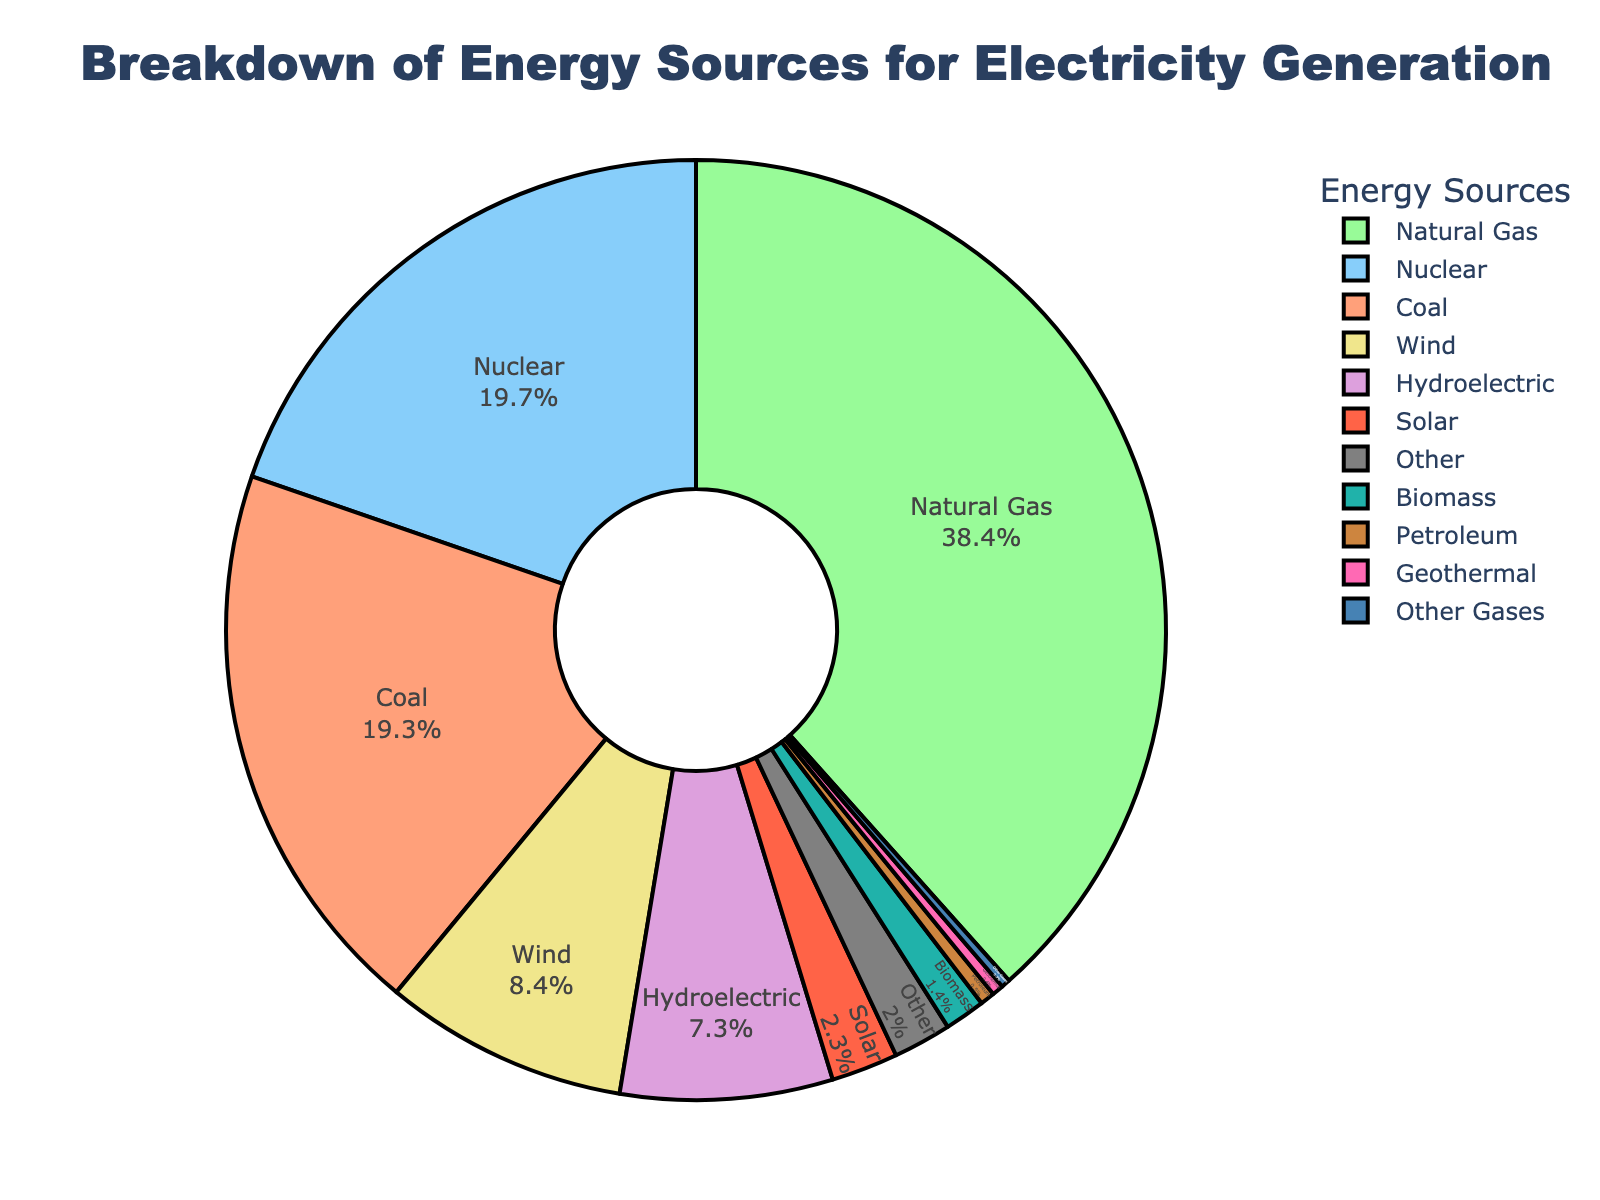What is the energy source with the highest percentage? Identify the energy source with the largest portion of the pie chart, which represents the highest percentage.
Answer: Natural Gas What is the combined percentage of Coal and Nuclear energy? Look at the percentages for Coal (19.3%) and Nuclear (19.7%) and sum them up: 19.3 + 19.7 = 39.0%
Answer: 39.0% Which energy sources have a percentage below 1%? Identify the segments of the pie chart that are visually small and check their labels: Geothermal (0.4%), Petroleum (0.5%), Other Gases (0.3%)
Answer: Geothermal, Petroleum, Other Gases Is the percentage of Wind energy greater than Solar energy? Compare the percentages of Wind (8.4%) and Solar (2.3%): 8.4% > 2.3%
Answer: Yes What color represents Hydroelectric energy in the chart? Identify the color associated with the Hydroelectric label in the pie chart. In this case, it's represented by a specific shade (yellow).
Answer: Yellow How much more percentage is Natural Gas compared to Coal? Calculate the difference between the percentages of Natural Gas (38.4%) and Coal (19.3%): 38.4 - 19.3 = 19.1%
Answer: 19.1% Which energy sources together contribute to over 50% of the total electricity generation? Sum the percentages of the largest segments until the total exceeds 50%. Natural Gas (38.4%) + Nuclear (19.7%) = 58.1%
Answer: Natural Gas, Nuclear What is the percentage difference between the smallest and the largest energy sources? Identify the smallest (Other Gases - 0.3%) and the largest (Natural Gas - 38.4%) percentages, then calculate the difference: 38.4 - 0.3 = 38.1%
Answer: 38.1% Which energy source is represented in pink and what is its percentage? Locate the pink segment in the pie chart and check its corresponding label and percentage. It represents Wind at 8.4%.
Answer: Wind, 8.4% What is the total percentage of renewable energy sources (Hydroelectric, Wind, Solar, Biomass, Geothermal)? Sum the percentages of all renewable energy sources: Hydroelectric (7.3%) + Wind (8.4%) + Solar (2.3%) + Biomass (1.4%) + Geothermal (0.4%) = 19.8%
Answer: 19.8% 